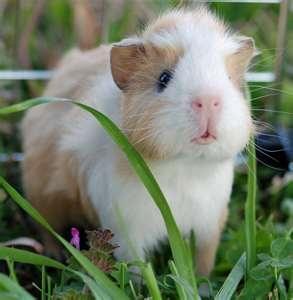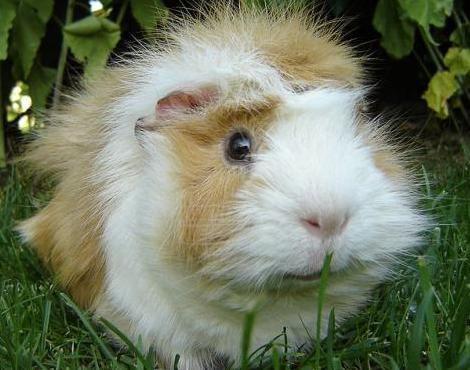The first image is the image on the left, the second image is the image on the right. Analyze the images presented: Is the assertion "One of the animals is brown." valid? Answer yes or no. No. 